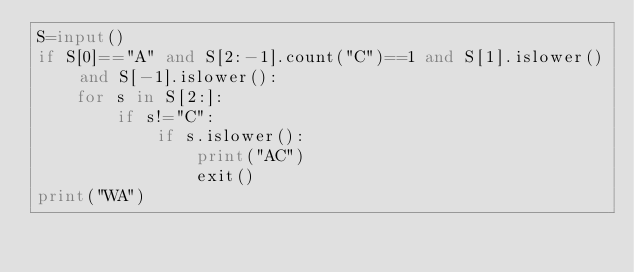<code> <loc_0><loc_0><loc_500><loc_500><_Python_>S=input()
if S[0]=="A" and S[2:-1].count("C")==1 and S[1].islower() and S[-1].islower():
    for s in S[2:]:
        if s!="C":
            if s.islower():
                print("AC")
                exit()
print("WA")

</code> 